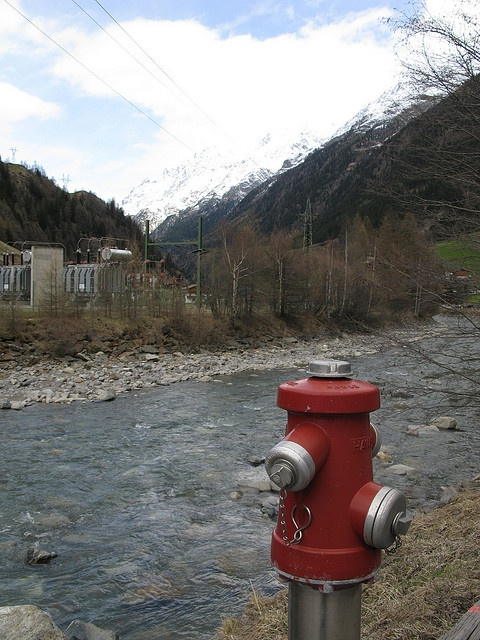Describe the objects in this image and their specific colors. I can see a fire hydrant in white, maroon, black, gray, and brown tones in this image. 